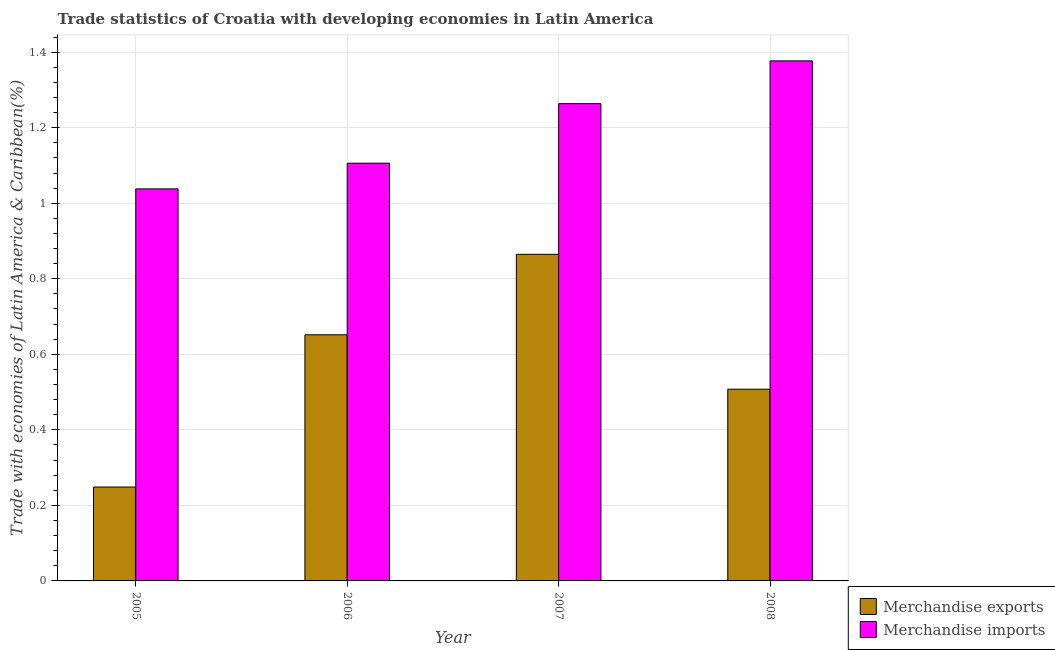Are the number of bars on each tick of the X-axis equal?
Provide a succinct answer. Yes. What is the label of the 2nd group of bars from the left?
Ensure brevity in your answer.  2006. What is the merchandise imports in 2007?
Your answer should be compact. 1.26. Across all years, what is the maximum merchandise exports?
Keep it short and to the point. 0.86. Across all years, what is the minimum merchandise imports?
Provide a succinct answer. 1.04. In which year was the merchandise exports maximum?
Provide a succinct answer. 2007. What is the total merchandise exports in the graph?
Offer a very short reply. 2.27. What is the difference between the merchandise exports in 2005 and that in 2008?
Make the answer very short. -0.26. What is the difference between the merchandise exports in 2005 and the merchandise imports in 2007?
Your response must be concise. -0.62. What is the average merchandise imports per year?
Give a very brief answer. 1.2. In the year 2006, what is the difference between the merchandise imports and merchandise exports?
Keep it short and to the point. 0. What is the ratio of the merchandise exports in 2005 to that in 2006?
Your answer should be very brief. 0.38. What is the difference between the highest and the second highest merchandise imports?
Your answer should be compact. 0.11. What is the difference between the highest and the lowest merchandise imports?
Give a very brief answer. 0.34. Is the sum of the merchandise imports in 2006 and 2008 greater than the maximum merchandise exports across all years?
Give a very brief answer. Yes. What does the 1st bar from the left in 2008 represents?
Offer a very short reply. Merchandise exports. What does the 1st bar from the right in 2007 represents?
Your answer should be very brief. Merchandise imports. How many bars are there?
Provide a succinct answer. 8. Are all the bars in the graph horizontal?
Offer a terse response. No. What is the difference between two consecutive major ticks on the Y-axis?
Give a very brief answer. 0.2. Are the values on the major ticks of Y-axis written in scientific E-notation?
Keep it short and to the point. No. Does the graph contain grids?
Your response must be concise. Yes. How are the legend labels stacked?
Your answer should be very brief. Vertical. What is the title of the graph?
Provide a succinct answer. Trade statistics of Croatia with developing economies in Latin America. What is the label or title of the X-axis?
Give a very brief answer. Year. What is the label or title of the Y-axis?
Ensure brevity in your answer.  Trade with economies of Latin America & Caribbean(%). What is the Trade with economies of Latin America & Caribbean(%) of Merchandise exports in 2005?
Offer a terse response. 0.25. What is the Trade with economies of Latin America & Caribbean(%) in Merchandise imports in 2005?
Offer a very short reply. 1.04. What is the Trade with economies of Latin America & Caribbean(%) of Merchandise exports in 2006?
Your response must be concise. 0.65. What is the Trade with economies of Latin America & Caribbean(%) in Merchandise imports in 2006?
Make the answer very short. 1.11. What is the Trade with economies of Latin America & Caribbean(%) of Merchandise exports in 2007?
Your answer should be very brief. 0.86. What is the Trade with economies of Latin America & Caribbean(%) in Merchandise imports in 2007?
Keep it short and to the point. 1.26. What is the Trade with economies of Latin America & Caribbean(%) in Merchandise exports in 2008?
Give a very brief answer. 0.51. What is the Trade with economies of Latin America & Caribbean(%) in Merchandise imports in 2008?
Your answer should be very brief. 1.38. Across all years, what is the maximum Trade with economies of Latin America & Caribbean(%) in Merchandise exports?
Provide a succinct answer. 0.86. Across all years, what is the maximum Trade with economies of Latin America & Caribbean(%) of Merchandise imports?
Ensure brevity in your answer.  1.38. Across all years, what is the minimum Trade with economies of Latin America & Caribbean(%) in Merchandise exports?
Make the answer very short. 0.25. Across all years, what is the minimum Trade with economies of Latin America & Caribbean(%) of Merchandise imports?
Offer a terse response. 1.04. What is the total Trade with economies of Latin America & Caribbean(%) of Merchandise exports in the graph?
Your answer should be compact. 2.27. What is the total Trade with economies of Latin America & Caribbean(%) in Merchandise imports in the graph?
Give a very brief answer. 4.78. What is the difference between the Trade with economies of Latin America & Caribbean(%) in Merchandise exports in 2005 and that in 2006?
Give a very brief answer. -0.4. What is the difference between the Trade with economies of Latin America & Caribbean(%) of Merchandise imports in 2005 and that in 2006?
Your answer should be very brief. -0.07. What is the difference between the Trade with economies of Latin America & Caribbean(%) of Merchandise exports in 2005 and that in 2007?
Your answer should be very brief. -0.62. What is the difference between the Trade with economies of Latin America & Caribbean(%) of Merchandise imports in 2005 and that in 2007?
Provide a succinct answer. -0.23. What is the difference between the Trade with economies of Latin America & Caribbean(%) in Merchandise exports in 2005 and that in 2008?
Your answer should be compact. -0.26. What is the difference between the Trade with economies of Latin America & Caribbean(%) in Merchandise imports in 2005 and that in 2008?
Give a very brief answer. -0.34. What is the difference between the Trade with economies of Latin America & Caribbean(%) of Merchandise exports in 2006 and that in 2007?
Keep it short and to the point. -0.21. What is the difference between the Trade with economies of Latin America & Caribbean(%) in Merchandise imports in 2006 and that in 2007?
Your answer should be compact. -0.16. What is the difference between the Trade with economies of Latin America & Caribbean(%) of Merchandise exports in 2006 and that in 2008?
Offer a terse response. 0.14. What is the difference between the Trade with economies of Latin America & Caribbean(%) of Merchandise imports in 2006 and that in 2008?
Your response must be concise. -0.27. What is the difference between the Trade with economies of Latin America & Caribbean(%) in Merchandise exports in 2007 and that in 2008?
Provide a succinct answer. 0.36. What is the difference between the Trade with economies of Latin America & Caribbean(%) of Merchandise imports in 2007 and that in 2008?
Provide a succinct answer. -0.11. What is the difference between the Trade with economies of Latin America & Caribbean(%) of Merchandise exports in 2005 and the Trade with economies of Latin America & Caribbean(%) of Merchandise imports in 2006?
Keep it short and to the point. -0.86. What is the difference between the Trade with economies of Latin America & Caribbean(%) of Merchandise exports in 2005 and the Trade with economies of Latin America & Caribbean(%) of Merchandise imports in 2007?
Your answer should be very brief. -1.01. What is the difference between the Trade with economies of Latin America & Caribbean(%) of Merchandise exports in 2005 and the Trade with economies of Latin America & Caribbean(%) of Merchandise imports in 2008?
Make the answer very short. -1.13. What is the difference between the Trade with economies of Latin America & Caribbean(%) in Merchandise exports in 2006 and the Trade with economies of Latin America & Caribbean(%) in Merchandise imports in 2007?
Your answer should be very brief. -0.61. What is the difference between the Trade with economies of Latin America & Caribbean(%) of Merchandise exports in 2006 and the Trade with economies of Latin America & Caribbean(%) of Merchandise imports in 2008?
Your answer should be very brief. -0.73. What is the difference between the Trade with economies of Latin America & Caribbean(%) in Merchandise exports in 2007 and the Trade with economies of Latin America & Caribbean(%) in Merchandise imports in 2008?
Offer a very short reply. -0.51. What is the average Trade with economies of Latin America & Caribbean(%) in Merchandise exports per year?
Make the answer very short. 0.57. What is the average Trade with economies of Latin America & Caribbean(%) of Merchandise imports per year?
Your response must be concise. 1.2. In the year 2005, what is the difference between the Trade with economies of Latin America & Caribbean(%) of Merchandise exports and Trade with economies of Latin America & Caribbean(%) of Merchandise imports?
Keep it short and to the point. -0.79. In the year 2006, what is the difference between the Trade with economies of Latin America & Caribbean(%) of Merchandise exports and Trade with economies of Latin America & Caribbean(%) of Merchandise imports?
Give a very brief answer. -0.45. In the year 2007, what is the difference between the Trade with economies of Latin America & Caribbean(%) in Merchandise exports and Trade with economies of Latin America & Caribbean(%) in Merchandise imports?
Provide a succinct answer. -0.4. In the year 2008, what is the difference between the Trade with economies of Latin America & Caribbean(%) in Merchandise exports and Trade with economies of Latin America & Caribbean(%) in Merchandise imports?
Offer a very short reply. -0.87. What is the ratio of the Trade with economies of Latin America & Caribbean(%) of Merchandise exports in 2005 to that in 2006?
Your answer should be compact. 0.38. What is the ratio of the Trade with economies of Latin America & Caribbean(%) in Merchandise imports in 2005 to that in 2006?
Give a very brief answer. 0.94. What is the ratio of the Trade with economies of Latin America & Caribbean(%) in Merchandise exports in 2005 to that in 2007?
Offer a terse response. 0.29. What is the ratio of the Trade with economies of Latin America & Caribbean(%) of Merchandise imports in 2005 to that in 2007?
Offer a very short reply. 0.82. What is the ratio of the Trade with economies of Latin America & Caribbean(%) in Merchandise exports in 2005 to that in 2008?
Your answer should be very brief. 0.49. What is the ratio of the Trade with economies of Latin America & Caribbean(%) in Merchandise imports in 2005 to that in 2008?
Provide a succinct answer. 0.75. What is the ratio of the Trade with economies of Latin America & Caribbean(%) in Merchandise exports in 2006 to that in 2007?
Give a very brief answer. 0.75. What is the ratio of the Trade with economies of Latin America & Caribbean(%) of Merchandise imports in 2006 to that in 2007?
Your answer should be very brief. 0.88. What is the ratio of the Trade with economies of Latin America & Caribbean(%) of Merchandise exports in 2006 to that in 2008?
Make the answer very short. 1.28. What is the ratio of the Trade with economies of Latin America & Caribbean(%) of Merchandise imports in 2006 to that in 2008?
Make the answer very short. 0.8. What is the ratio of the Trade with economies of Latin America & Caribbean(%) in Merchandise exports in 2007 to that in 2008?
Provide a short and direct response. 1.7. What is the ratio of the Trade with economies of Latin America & Caribbean(%) in Merchandise imports in 2007 to that in 2008?
Offer a very short reply. 0.92. What is the difference between the highest and the second highest Trade with economies of Latin America & Caribbean(%) in Merchandise exports?
Make the answer very short. 0.21. What is the difference between the highest and the second highest Trade with economies of Latin America & Caribbean(%) in Merchandise imports?
Your response must be concise. 0.11. What is the difference between the highest and the lowest Trade with economies of Latin America & Caribbean(%) of Merchandise exports?
Make the answer very short. 0.62. What is the difference between the highest and the lowest Trade with economies of Latin America & Caribbean(%) of Merchandise imports?
Your answer should be compact. 0.34. 